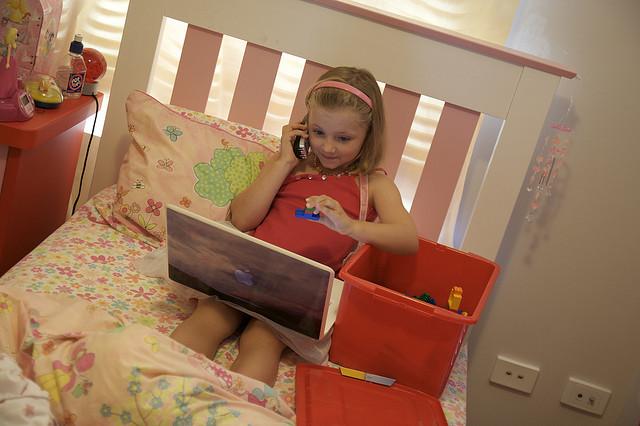What is the little girl doing?
Quick response, please. Talking on phone. What color is the tote beside her?
Quick response, please. Orange. What cartoon character is on the pink pillow?
Keep it brief. Flowers. Is this kid playing hide and seek?
Short answer required. No. Is this girl old enough to qualify for a cell phone plan?
Give a very brief answer. No. 